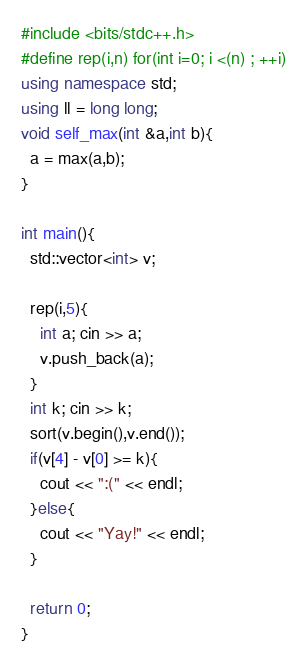<code> <loc_0><loc_0><loc_500><loc_500><_C++_>#include <bits/stdc++.h>
#define rep(i,n) for(int i=0; i <(n) ; ++i)
using namespace std;
using ll = long long;
void self_max(int &a,int b){
  a = max(a,b);
}

int main(){
  std::vector<int> v;
  
  rep(i,5){
    int a; cin >> a;
    v.push_back(a);
  }
  int k; cin >> k;
  sort(v.begin(),v.end());
  if(v[4] - v[0] >= k){
    cout << ":(" << endl;
  }else{
    cout << "Yay!" << endl;
  }

  return 0;
}
</code> 